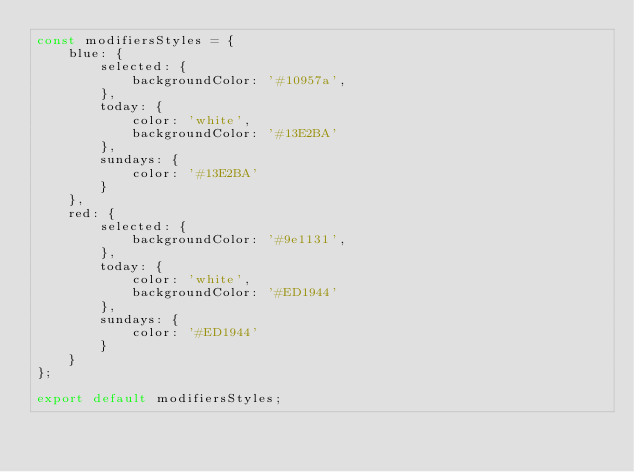Convert code to text. <code><loc_0><loc_0><loc_500><loc_500><_JavaScript_>const modifiersStyles = {
    blue: {
        selected: {
            backgroundColor: '#10957a',
        },
        today: {
            color: 'white',
            backgroundColor: '#13E2BA'
        },
        sundays: {
            color: '#13E2BA'
        }
    },
    red: {
        selected: {
            backgroundColor: '#9e1131',
        },
        today: {
            color: 'white',
            backgroundColor: '#ED1944'
        },
        sundays: {
            color: '#ED1944'
        }
    }
};

export default modifiersStyles;
</code> 